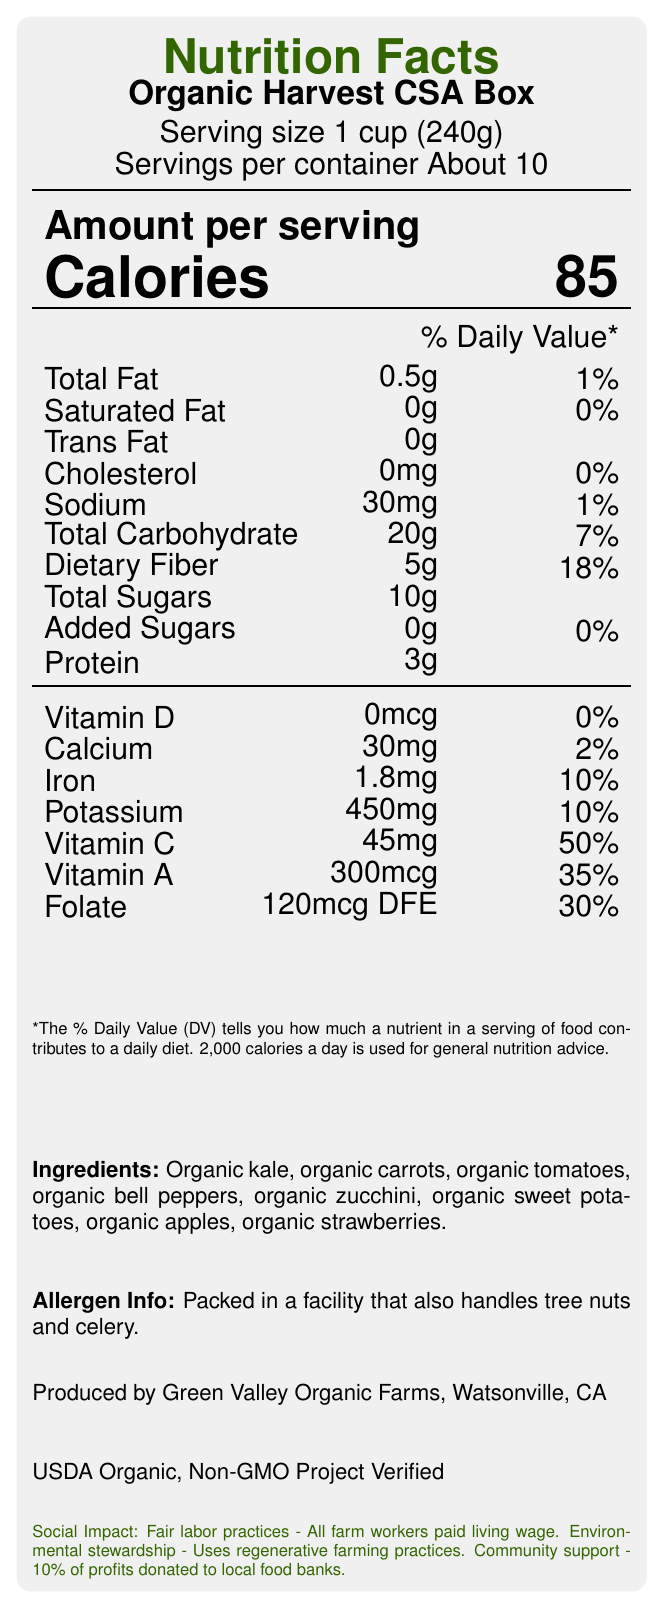who produces the Organic Harvest CSA Box? The bottom of the document states, "Produced by Green Valley Organic Farms, Watsonville, CA."
Answer: Green Valley Organic Farms, Watsonville, CA what is the serving size for the Organic Harvest CSA Box? Serving size information is given near the top of the document as "Serving size 1 cup (240g)."
Answer: 1 cup (240g) how many calories are in one serving? The document lists "Calories 85" in a large, bold font in the middle of the nutritional information.
Answer: 85 what is the percentage of daily value for dietary fiber per serving? The document shows "Dietary Fiber" as 5g and "18%" in its respective daily value column.
Answer: 18% what certifications does the Organic Harvest CSA Box have? At the bottom of the document, it mentions "USDA Organic, Non-GMO Project Verified."
Answer: USDA Organic, Non-GMO Project Verified how much sodium is in one serving of the Organic Harvest CSA Box? A. 10mg B. 30mg C. 50mg D. 100mg The label lists "Sodium" as "30mg" and its percentage daily value as "1%".
Answer: B which ingredient is NOT listed in the Organic Harvest CSA Box? A. Organic kale B. Organic carrots C. Organic lettuce D. Organic zucchini The ingredient list includes organic kale, carrots, tomatoes, bell peppers, zucchini, sweet potatoes, apples, and strawberries, but not lettuce.
Answer: C does the Organic Harvest CSA Box contain any added sugars? Under "Added Sugars," the document states "0g" and "0%" for its daily value.
Answer: No is the Organic Harvest CSA Box packed in a facility that handles tree nuts? The document states, "Packed in a facility that also handles tree nuts and celery."
Answer: Yes summarize the main idea of the Nutrition Facts Label for the Organic Harvest CSA Box. The detailed description includes serving size, calories, amounts and daily values of fats, cholesterol, sodium, carbohydrates, fiber, sugars, protein, vitamins, and minerals. It also lists the ingredients and certifies organic production and non-GMO verification, alongside social impacts like fair labor practices, community support, and environmental stewardship.
Answer: The Nutrition Facts Label provides detailed information about the nutritional content, ingredients, allergen info, and certifications of the Organic Harvest CSA Box. It highlights that the product is organic, non-GMO, and produced by Green Valley Organic Farms. It also emphasizes the social impacts including fair labor practices, environmental stewardship, and community support. how many servings are there in a container of Organic Harvest CSA Box? The document specifies "Servings per container About 10" near the top.
Answer: About 10 what is the percentage of daily value for Iron per serving? The label indicates "Iron" has a daily value of "10%".
Answer: 10% what are the fair labor practices mentioned for the Organic Harvest CSA Box? The social impact section at the bottom mentions, "Fair labor practices - All farm workers paid living wage."
Answer: All farm workers paid living wage 